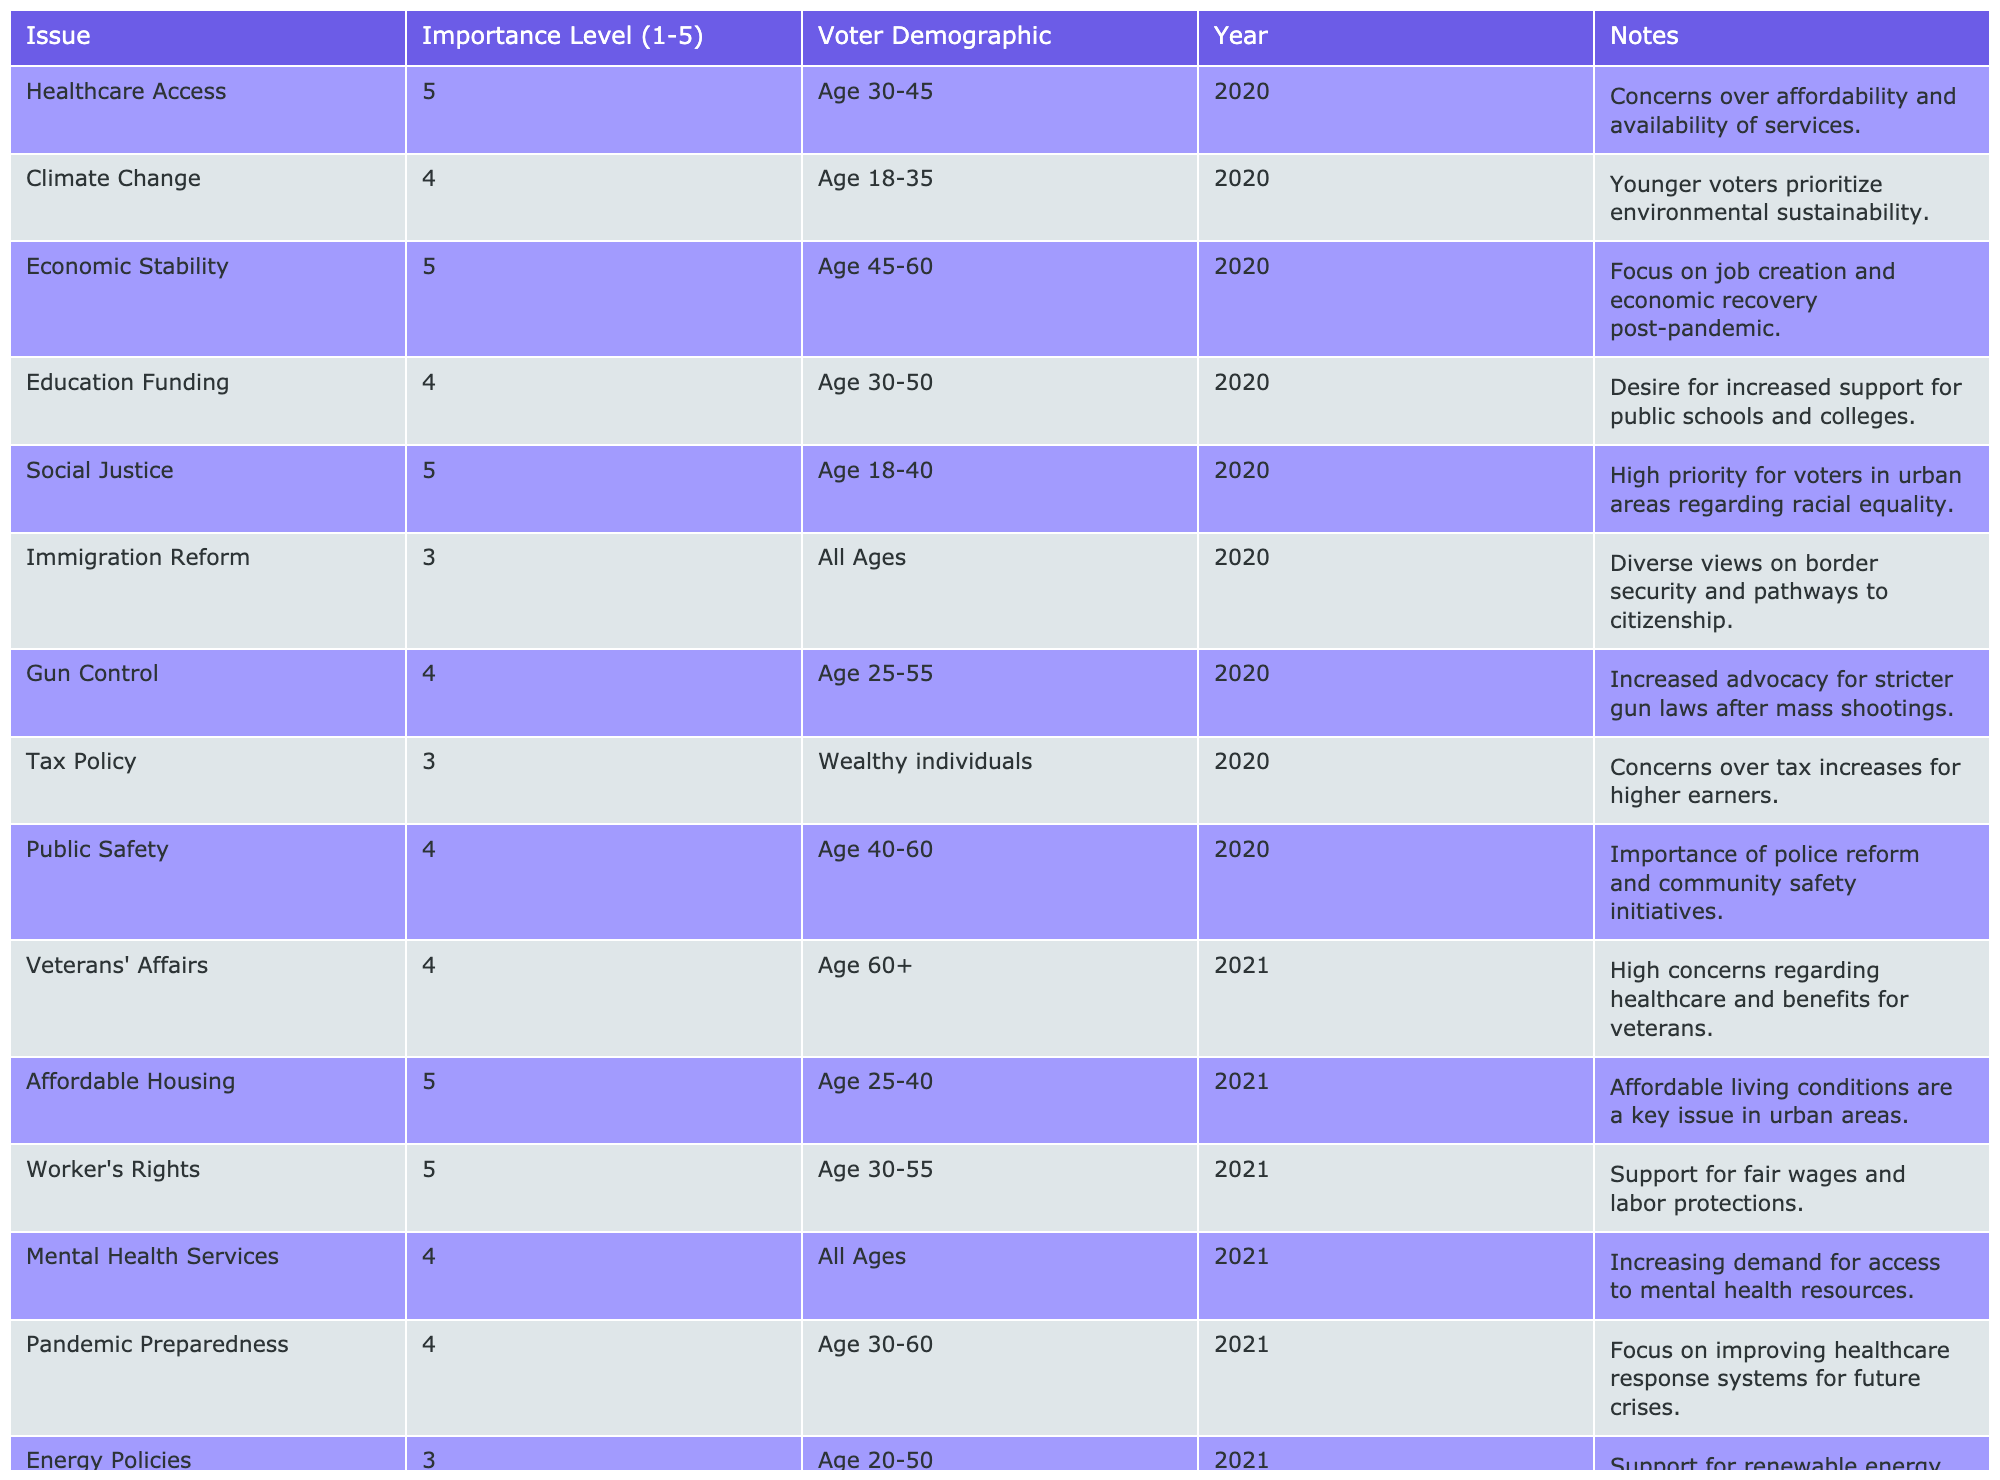What issue has the highest importance level among voters aged 30-45 in 2020? The issue with the highest importance level (5) for voters aged 30-45 in 2020 is Healthcare Access.
Answer: Healthcare Access How many issues were prioritized by voters aged 18-35 in 2020? There are two issues (Climate Change and Social Justice) prioritized by voters aged 18-35 in 2020.
Answer: 2 What is the average importance level of issues for voters aged 60 and above in 2021? There is one issue (Veterans' Affairs) with an importance level of 4 for voters aged 60 and above in 2021, so the average remains 4.
Answer: 4 Is Economic Stability considered important (level 4 or above) by any voter demographic? Yes, Economic Stability is prioritized with an importance level of 5 by voters aged 45-60 in 2020.
Answer: Yes Which age group prioritized Women's Rights as a critical issue in 2021, and what was its importance level? Voters aged 18-45 prioritized Women's Rights as a critical issue in 2021, with an importance level of 5.
Answer: Age 18-45, Importance Level 5 How many issues have a priority of importance level 3 and lower on average across all years? There are six issues (Immigration Reform, Tax Policy, Energy Policies, Corporate Regulation, Transportation Issues, Foreign Policy) with an average importance level of 3, since they all score 3.
Answer: 3 What issues were considered the highest priority (level 5) in 2021? In 2021, the highest priority issues (level 5) are Affordable Housing, Worker's Rights, and Women's Rights.
Answer: Affordable Housing, Worker's Rights, Women's Rights Which voter demographic placed the least importance on Gun Control and what was that level? The demographic for Gun Control was not specified to place a low importance level since the importance is 4 for Age 25-55.
Answer: None What is the difference in importance level between the most prioritized issue and the least prioritized issue across both years? The most prioritized issue has an importance of 5, while the least is 3, so the difference is 5 - 3 = 2.
Answer: 2 How many total issues have an importance level of 4 in the year 2020? There are four issues (Climate Change, Education Funding, Gun Control, Social Justice) with an importance level of 4 in 2020.
Answer: 4 